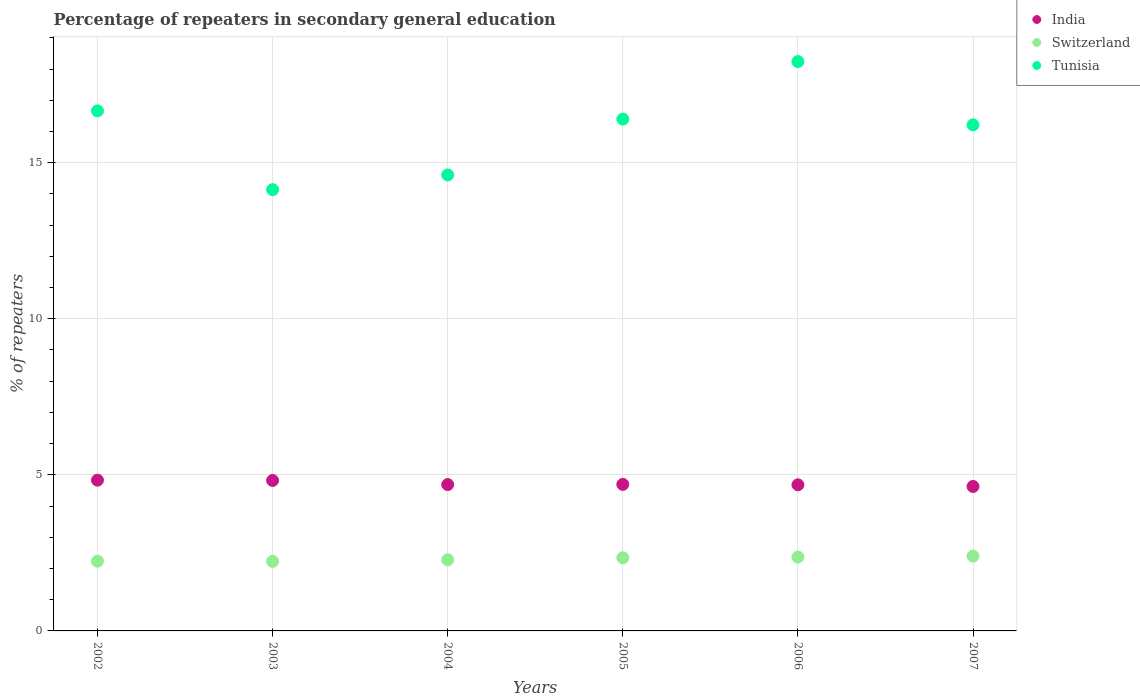How many different coloured dotlines are there?
Your answer should be very brief. 3. What is the percentage of repeaters in secondary general education in Switzerland in 2002?
Offer a terse response. 2.23. Across all years, what is the maximum percentage of repeaters in secondary general education in Switzerland?
Offer a very short reply. 2.4. Across all years, what is the minimum percentage of repeaters in secondary general education in India?
Your answer should be compact. 4.63. In which year was the percentage of repeaters in secondary general education in Tunisia maximum?
Provide a succinct answer. 2006. What is the total percentage of repeaters in secondary general education in Switzerland in the graph?
Your answer should be very brief. 13.85. What is the difference between the percentage of repeaters in secondary general education in Switzerland in 2002 and that in 2004?
Your answer should be very brief. -0.05. What is the difference between the percentage of repeaters in secondary general education in Tunisia in 2002 and the percentage of repeaters in secondary general education in India in 2007?
Your response must be concise. 12.03. What is the average percentage of repeaters in secondary general education in Switzerland per year?
Your answer should be very brief. 2.31. In the year 2007, what is the difference between the percentage of repeaters in secondary general education in India and percentage of repeaters in secondary general education in Tunisia?
Provide a short and direct response. -11.58. What is the ratio of the percentage of repeaters in secondary general education in India in 2005 to that in 2006?
Provide a short and direct response. 1. Is the difference between the percentage of repeaters in secondary general education in India in 2005 and 2006 greater than the difference between the percentage of repeaters in secondary general education in Tunisia in 2005 and 2006?
Provide a succinct answer. Yes. What is the difference between the highest and the second highest percentage of repeaters in secondary general education in Tunisia?
Give a very brief answer. 1.58. What is the difference between the highest and the lowest percentage of repeaters in secondary general education in India?
Your answer should be very brief. 0.2. In how many years, is the percentage of repeaters in secondary general education in Switzerland greater than the average percentage of repeaters in secondary general education in Switzerland taken over all years?
Ensure brevity in your answer.  3. Is the sum of the percentage of repeaters in secondary general education in India in 2006 and 2007 greater than the maximum percentage of repeaters in secondary general education in Switzerland across all years?
Keep it short and to the point. Yes. Is it the case that in every year, the sum of the percentage of repeaters in secondary general education in India and percentage of repeaters in secondary general education in Switzerland  is greater than the percentage of repeaters in secondary general education in Tunisia?
Make the answer very short. No. Does the percentage of repeaters in secondary general education in Tunisia monotonically increase over the years?
Offer a terse response. No. Is the percentage of repeaters in secondary general education in India strictly less than the percentage of repeaters in secondary general education in Tunisia over the years?
Ensure brevity in your answer.  Yes. What is the difference between two consecutive major ticks on the Y-axis?
Offer a very short reply. 5. Where does the legend appear in the graph?
Make the answer very short. Top right. What is the title of the graph?
Give a very brief answer. Percentage of repeaters in secondary general education. What is the label or title of the X-axis?
Provide a succinct answer. Years. What is the label or title of the Y-axis?
Offer a very short reply. % of repeaters. What is the % of repeaters of India in 2002?
Your response must be concise. 4.83. What is the % of repeaters in Switzerland in 2002?
Offer a terse response. 2.23. What is the % of repeaters of Tunisia in 2002?
Give a very brief answer. 16.66. What is the % of repeaters of India in 2003?
Offer a terse response. 4.82. What is the % of repeaters in Switzerland in 2003?
Give a very brief answer. 2.23. What is the % of repeaters of Tunisia in 2003?
Offer a terse response. 14.14. What is the % of repeaters of India in 2004?
Offer a terse response. 4.69. What is the % of repeaters in Switzerland in 2004?
Make the answer very short. 2.28. What is the % of repeaters of Tunisia in 2004?
Your response must be concise. 14.61. What is the % of repeaters of India in 2005?
Your answer should be very brief. 4.69. What is the % of repeaters of Switzerland in 2005?
Your answer should be very brief. 2.34. What is the % of repeaters of Tunisia in 2005?
Keep it short and to the point. 16.4. What is the % of repeaters in India in 2006?
Make the answer very short. 4.68. What is the % of repeaters of Switzerland in 2006?
Offer a very short reply. 2.37. What is the % of repeaters in Tunisia in 2006?
Offer a terse response. 18.24. What is the % of repeaters of India in 2007?
Make the answer very short. 4.63. What is the % of repeaters of Switzerland in 2007?
Offer a very short reply. 2.4. What is the % of repeaters in Tunisia in 2007?
Offer a terse response. 16.21. Across all years, what is the maximum % of repeaters of India?
Your answer should be very brief. 4.83. Across all years, what is the maximum % of repeaters of Switzerland?
Offer a terse response. 2.4. Across all years, what is the maximum % of repeaters of Tunisia?
Make the answer very short. 18.24. Across all years, what is the minimum % of repeaters in India?
Offer a terse response. 4.63. Across all years, what is the minimum % of repeaters in Switzerland?
Your response must be concise. 2.23. Across all years, what is the minimum % of repeaters of Tunisia?
Give a very brief answer. 14.14. What is the total % of repeaters of India in the graph?
Make the answer very short. 28.34. What is the total % of repeaters in Switzerland in the graph?
Give a very brief answer. 13.85. What is the total % of repeaters of Tunisia in the graph?
Give a very brief answer. 96.26. What is the difference between the % of repeaters of India in 2002 and that in 2003?
Give a very brief answer. 0.01. What is the difference between the % of repeaters of Switzerland in 2002 and that in 2003?
Keep it short and to the point. 0.01. What is the difference between the % of repeaters in Tunisia in 2002 and that in 2003?
Your answer should be compact. 2.52. What is the difference between the % of repeaters of India in 2002 and that in 2004?
Provide a short and direct response. 0.14. What is the difference between the % of repeaters in Switzerland in 2002 and that in 2004?
Give a very brief answer. -0.05. What is the difference between the % of repeaters of Tunisia in 2002 and that in 2004?
Ensure brevity in your answer.  2.05. What is the difference between the % of repeaters of India in 2002 and that in 2005?
Your answer should be compact. 0.13. What is the difference between the % of repeaters in Switzerland in 2002 and that in 2005?
Your response must be concise. -0.11. What is the difference between the % of repeaters in Tunisia in 2002 and that in 2005?
Make the answer very short. 0.26. What is the difference between the % of repeaters of India in 2002 and that in 2006?
Your answer should be very brief. 0.15. What is the difference between the % of repeaters of Switzerland in 2002 and that in 2006?
Provide a succinct answer. -0.13. What is the difference between the % of repeaters in Tunisia in 2002 and that in 2006?
Offer a terse response. -1.58. What is the difference between the % of repeaters of India in 2002 and that in 2007?
Provide a short and direct response. 0.2. What is the difference between the % of repeaters in Switzerland in 2002 and that in 2007?
Provide a succinct answer. -0.16. What is the difference between the % of repeaters of Tunisia in 2002 and that in 2007?
Your answer should be very brief. 0.45. What is the difference between the % of repeaters in India in 2003 and that in 2004?
Provide a succinct answer. 0.13. What is the difference between the % of repeaters of Switzerland in 2003 and that in 2004?
Your response must be concise. -0.05. What is the difference between the % of repeaters in Tunisia in 2003 and that in 2004?
Provide a short and direct response. -0.47. What is the difference between the % of repeaters in India in 2003 and that in 2005?
Give a very brief answer. 0.13. What is the difference between the % of repeaters of Switzerland in 2003 and that in 2005?
Offer a terse response. -0.12. What is the difference between the % of repeaters in Tunisia in 2003 and that in 2005?
Give a very brief answer. -2.26. What is the difference between the % of repeaters in India in 2003 and that in 2006?
Keep it short and to the point. 0.14. What is the difference between the % of repeaters of Switzerland in 2003 and that in 2006?
Make the answer very short. -0.14. What is the difference between the % of repeaters in Tunisia in 2003 and that in 2006?
Keep it short and to the point. -4.1. What is the difference between the % of repeaters of India in 2003 and that in 2007?
Your response must be concise. 0.19. What is the difference between the % of repeaters in Switzerland in 2003 and that in 2007?
Provide a short and direct response. -0.17. What is the difference between the % of repeaters of Tunisia in 2003 and that in 2007?
Your answer should be very brief. -2.08. What is the difference between the % of repeaters of India in 2004 and that in 2005?
Ensure brevity in your answer.  -0.01. What is the difference between the % of repeaters in Switzerland in 2004 and that in 2005?
Keep it short and to the point. -0.06. What is the difference between the % of repeaters of Tunisia in 2004 and that in 2005?
Offer a terse response. -1.79. What is the difference between the % of repeaters of India in 2004 and that in 2006?
Your response must be concise. 0.01. What is the difference between the % of repeaters of Switzerland in 2004 and that in 2006?
Your answer should be compact. -0.09. What is the difference between the % of repeaters in Tunisia in 2004 and that in 2006?
Give a very brief answer. -3.63. What is the difference between the % of repeaters in India in 2004 and that in 2007?
Make the answer very short. 0.06. What is the difference between the % of repeaters in Switzerland in 2004 and that in 2007?
Your response must be concise. -0.12. What is the difference between the % of repeaters in Tunisia in 2004 and that in 2007?
Provide a short and direct response. -1.6. What is the difference between the % of repeaters of India in 2005 and that in 2006?
Provide a short and direct response. 0.01. What is the difference between the % of repeaters in Switzerland in 2005 and that in 2006?
Make the answer very short. -0.02. What is the difference between the % of repeaters of Tunisia in 2005 and that in 2006?
Make the answer very short. -1.84. What is the difference between the % of repeaters of India in 2005 and that in 2007?
Your answer should be very brief. 0.07. What is the difference between the % of repeaters in Switzerland in 2005 and that in 2007?
Keep it short and to the point. -0.05. What is the difference between the % of repeaters of Tunisia in 2005 and that in 2007?
Provide a short and direct response. 0.19. What is the difference between the % of repeaters in India in 2006 and that in 2007?
Ensure brevity in your answer.  0.05. What is the difference between the % of repeaters of Switzerland in 2006 and that in 2007?
Your answer should be compact. -0.03. What is the difference between the % of repeaters in Tunisia in 2006 and that in 2007?
Keep it short and to the point. 2.03. What is the difference between the % of repeaters of India in 2002 and the % of repeaters of Switzerland in 2003?
Offer a very short reply. 2.6. What is the difference between the % of repeaters in India in 2002 and the % of repeaters in Tunisia in 2003?
Your answer should be compact. -9.31. What is the difference between the % of repeaters in Switzerland in 2002 and the % of repeaters in Tunisia in 2003?
Provide a short and direct response. -11.9. What is the difference between the % of repeaters of India in 2002 and the % of repeaters of Switzerland in 2004?
Your answer should be very brief. 2.55. What is the difference between the % of repeaters in India in 2002 and the % of repeaters in Tunisia in 2004?
Provide a succinct answer. -9.78. What is the difference between the % of repeaters in Switzerland in 2002 and the % of repeaters in Tunisia in 2004?
Ensure brevity in your answer.  -12.38. What is the difference between the % of repeaters of India in 2002 and the % of repeaters of Switzerland in 2005?
Offer a very short reply. 2.49. What is the difference between the % of repeaters of India in 2002 and the % of repeaters of Tunisia in 2005?
Provide a succinct answer. -11.57. What is the difference between the % of repeaters of Switzerland in 2002 and the % of repeaters of Tunisia in 2005?
Provide a succinct answer. -14.16. What is the difference between the % of repeaters of India in 2002 and the % of repeaters of Switzerland in 2006?
Make the answer very short. 2.46. What is the difference between the % of repeaters in India in 2002 and the % of repeaters in Tunisia in 2006?
Your answer should be compact. -13.41. What is the difference between the % of repeaters in Switzerland in 2002 and the % of repeaters in Tunisia in 2006?
Give a very brief answer. -16.01. What is the difference between the % of repeaters in India in 2002 and the % of repeaters in Switzerland in 2007?
Ensure brevity in your answer.  2.43. What is the difference between the % of repeaters of India in 2002 and the % of repeaters of Tunisia in 2007?
Make the answer very short. -11.38. What is the difference between the % of repeaters in Switzerland in 2002 and the % of repeaters in Tunisia in 2007?
Offer a terse response. -13.98. What is the difference between the % of repeaters of India in 2003 and the % of repeaters of Switzerland in 2004?
Offer a very short reply. 2.54. What is the difference between the % of repeaters of India in 2003 and the % of repeaters of Tunisia in 2004?
Your answer should be very brief. -9.79. What is the difference between the % of repeaters of Switzerland in 2003 and the % of repeaters of Tunisia in 2004?
Your answer should be compact. -12.38. What is the difference between the % of repeaters of India in 2003 and the % of repeaters of Switzerland in 2005?
Your response must be concise. 2.48. What is the difference between the % of repeaters in India in 2003 and the % of repeaters in Tunisia in 2005?
Make the answer very short. -11.58. What is the difference between the % of repeaters in Switzerland in 2003 and the % of repeaters in Tunisia in 2005?
Keep it short and to the point. -14.17. What is the difference between the % of repeaters of India in 2003 and the % of repeaters of Switzerland in 2006?
Offer a very short reply. 2.45. What is the difference between the % of repeaters of India in 2003 and the % of repeaters of Tunisia in 2006?
Your answer should be very brief. -13.42. What is the difference between the % of repeaters in Switzerland in 2003 and the % of repeaters in Tunisia in 2006?
Your answer should be compact. -16.01. What is the difference between the % of repeaters in India in 2003 and the % of repeaters in Switzerland in 2007?
Offer a very short reply. 2.42. What is the difference between the % of repeaters in India in 2003 and the % of repeaters in Tunisia in 2007?
Your response must be concise. -11.39. What is the difference between the % of repeaters in Switzerland in 2003 and the % of repeaters in Tunisia in 2007?
Provide a succinct answer. -13.98. What is the difference between the % of repeaters in India in 2004 and the % of repeaters in Switzerland in 2005?
Your response must be concise. 2.34. What is the difference between the % of repeaters in India in 2004 and the % of repeaters in Tunisia in 2005?
Provide a short and direct response. -11.71. What is the difference between the % of repeaters in Switzerland in 2004 and the % of repeaters in Tunisia in 2005?
Ensure brevity in your answer.  -14.12. What is the difference between the % of repeaters in India in 2004 and the % of repeaters in Switzerland in 2006?
Make the answer very short. 2.32. What is the difference between the % of repeaters in India in 2004 and the % of repeaters in Tunisia in 2006?
Provide a short and direct response. -13.55. What is the difference between the % of repeaters of Switzerland in 2004 and the % of repeaters of Tunisia in 2006?
Offer a very short reply. -15.96. What is the difference between the % of repeaters in India in 2004 and the % of repeaters in Switzerland in 2007?
Provide a succinct answer. 2.29. What is the difference between the % of repeaters in India in 2004 and the % of repeaters in Tunisia in 2007?
Ensure brevity in your answer.  -11.52. What is the difference between the % of repeaters of Switzerland in 2004 and the % of repeaters of Tunisia in 2007?
Give a very brief answer. -13.93. What is the difference between the % of repeaters in India in 2005 and the % of repeaters in Switzerland in 2006?
Keep it short and to the point. 2.33. What is the difference between the % of repeaters of India in 2005 and the % of repeaters of Tunisia in 2006?
Keep it short and to the point. -13.55. What is the difference between the % of repeaters of Switzerland in 2005 and the % of repeaters of Tunisia in 2006?
Give a very brief answer. -15.9. What is the difference between the % of repeaters in India in 2005 and the % of repeaters in Switzerland in 2007?
Keep it short and to the point. 2.3. What is the difference between the % of repeaters of India in 2005 and the % of repeaters of Tunisia in 2007?
Your response must be concise. -11.52. What is the difference between the % of repeaters in Switzerland in 2005 and the % of repeaters in Tunisia in 2007?
Your response must be concise. -13.87. What is the difference between the % of repeaters of India in 2006 and the % of repeaters of Switzerland in 2007?
Make the answer very short. 2.28. What is the difference between the % of repeaters of India in 2006 and the % of repeaters of Tunisia in 2007?
Give a very brief answer. -11.53. What is the difference between the % of repeaters in Switzerland in 2006 and the % of repeaters in Tunisia in 2007?
Provide a succinct answer. -13.85. What is the average % of repeaters in India per year?
Your answer should be compact. 4.72. What is the average % of repeaters of Switzerland per year?
Give a very brief answer. 2.31. What is the average % of repeaters of Tunisia per year?
Provide a succinct answer. 16.04. In the year 2002, what is the difference between the % of repeaters of India and % of repeaters of Switzerland?
Give a very brief answer. 2.6. In the year 2002, what is the difference between the % of repeaters in India and % of repeaters in Tunisia?
Your answer should be compact. -11.83. In the year 2002, what is the difference between the % of repeaters of Switzerland and % of repeaters of Tunisia?
Your response must be concise. -14.43. In the year 2003, what is the difference between the % of repeaters in India and % of repeaters in Switzerland?
Make the answer very short. 2.59. In the year 2003, what is the difference between the % of repeaters of India and % of repeaters of Tunisia?
Offer a terse response. -9.32. In the year 2003, what is the difference between the % of repeaters in Switzerland and % of repeaters in Tunisia?
Your response must be concise. -11.91. In the year 2004, what is the difference between the % of repeaters of India and % of repeaters of Switzerland?
Provide a short and direct response. 2.41. In the year 2004, what is the difference between the % of repeaters in India and % of repeaters in Tunisia?
Make the answer very short. -9.92. In the year 2004, what is the difference between the % of repeaters in Switzerland and % of repeaters in Tunisia?
Make the answer very short. -12.33. In the year 2005, what is the difference between the % of repeaters in India and % of repeaters in Switzerland?
Give a very brief answer. 2.35. In the year 2005, what is the difference between the % of repeaters of India and % of repeaters of Tunisia?
Your response must be concise. -11.7. In the year 2005, what is the difference between the % of repeaters in Switzerland and % of repeaters in Tunisia?
Offer a very short reply. -14.05. In the year 2006, what is the difference between the % of repeaters in India and % of repeaters in Switzerland?
Your answer should be very brief. 2.31. In the year 2006, what is the difference between the % of repeaters of India and % of repeaters of Tunisia?
Make the answer very short. -13.56. In the year 2006, what is the difference between the % of repeaters of Switzerland and % of repeaters of Tunisia?
Offer a terse response. -15.87. In the year 2007, what is the difference between the % of repeaters in India and % of repeaters in Switzerland?
Make the answer very short. 2.23. In the year 2007, what is the difference between the % of repeaters in India and % of repeaters in Tunisia?
Provide a succinct answer. -11.58. In the year 2007, what is the difference between the % of repeaters in Switzerland and % of repeaters in Tunisia?
Keep it short and to the point. -13.82. What is the ratio of the % of repeaters of Tunisia in 2002 to that in 2003?
Your answer should be compact. 1.18. What is the ratio of the % of repeaters in Switzerland in 2002 to that in 2004?
Your response must be concise. 0.98. What is the ratio of the % of repeaters of Tunisia in 2002 to that in 2004?
Keep it short and to the point. 1.14. What is the ratio of the % of repeaters of India in 2002 to that in 2005?
Provide a short and direct response. 1.03. What is the ratio of the % of repeaters in Switzerland in 2002 to that in 2005?
Provide a short and direct response. 0.95. What is the ratio of the % of repeaters of India in 2002 to that in 2006?
Keep it short and to the point. 1.03. What is the ratio of the % of repeaters of Switzerland in 2002 to that in 2006?
Offer a very short reply. 0.94. What is the ratio of the % of repeaters of Tunisia in 2002 to that in 2006?
Offer a terse response. 0.91. What is the ratio of the % of repeaters in India in 2002 to that in 2007?
Your answer should be very brief. 1.04. What is the ratio of the % of repeaters in Switzerland in 2002 to that in 2007?
Your response must be concise. 0.93. What is the ratio of the % of repeaters in Tunisia in 2002 to that in 2007?
Provide a succinct answer. 1.03. What is the ratio of the % of repeaters of India in 2003 to that in 2004?
Offer a terse response. 1.03. What is the ratio of the % of repeaters in Switzerland in 2003 to that in 2004?
Give a very brief answer. 0.98. What is the ratio of the % of repeaters of Tunisia in 2003 to that in 2004?
Keep it short and to the point. 0.97. What is the ratio of the % of repeaters in India in 2003 to that in 2005?
Offer a terse response. 1.03. What is the ratio of the % of repeaters of Switzerland in 2003 to that in 2005?
Ensure brevity in your answer.  0.95. What is the ratio of the % of repeaters in Tunisia in 2003 to that in 2005?
Your answer should be compact. 0.86. What is the ratio of the % of repeaters in India in 2003 to that in 2006?
Offer a terse response. 1.03. What is the ratio of the % of repeaters in Switzerland in 2003 to that in 2006?
Give a very brief answer. 0.94. What is the ratio of the % of repeaters in Tunisia in 2003 to that in 2006?
Give a very brief answer. 0.78. What is the ratio of the % of repeaters in India in 2003 to that in 2007?
Give a very brief answer. 1.04. What is the ratio of the % of repeaters of Tunisia in 2003 to that in 2007?
Give a very brief answer. 0.87. What is the ratio of the % of repeaters of Switzerland in 2004 to that in 2005?
Make the answer very short. 0.97. What is the ratio of the % of repeaters in Tunisia in 2004 to that in 2005?
Your response must be concise. 0.89. What is the ratio of the % of repeaters of Switzerland in 2004 to that in 2006?
Ensure brevity in your answer.  0.96. What is the ratio of the % of repeaters in Tunisia in 2004 to that in 2006?
Provide a succinct answer. 0.8. What is the ratio of the % of repeaters in India in 2004 to that in 2007?
Ensure brevity in your answer.  1.01. What is the ratio of the % of repeaters of Switzerland in 2004 to that in 2007?
Your response must be concise. 0.95. What is the ratio of the % of repeaters in Tunisia in 2004 to that in 2007?
Provide a short and direct response. 0.9. What is the ratio of the % of repeaters of India in 2005 to that in 2006?
Make the answer very short. 1. What is the ratio of the % of repeaters of Switzerland in 2005 to that in 2006?
Offer a terse response. 0.99. What is the ratio of the % of repeaters of Tunisia in 2005 to that in 2006?
Provide a succinct answer. 0.9. What is the ratio of the % of repeaters in India in 2005 to that in 2007?
Your response must be concise. 1.01. What is the ratio of the % of repeaters in Switzerland in 2005 to that in 2007?
Keep it short and to the point. 0.98. What is the ratio of the % of repeaters in Tunisia in 2005 to that in 2007?
Provide a succinct answer. 1.01. What is the ratio of the % of repeaters in India in 2006 to that in 2007?
Provide a short and direct response. 1.01. What is the ratio of the % of repeaters of Switzerland in 2006 to that in 2007?
Offer a very short reply. 0.99. What is the ratio of the % of repeaters of Tunisia in 2006 to that in 2007?
Make the answer very short. 1.13. What is the difference between the highest and the second highest % of repeaters of India?
Offer a very short reply. 0.01. What is the difference between the highest and the second highest % of repeaters in Switzerland?
Give a very brief answer. 0.03. What is the difference between the highest and the second highest % of repeaters in Tunisia?
Your response must be concise. 1.58. What is the difference between the highest and the lowest % of repeaters in India?
Provide a succinct answer. 0.2. What is the difference between the highest and the lowest % of repeaters of Switzerland?
Your response must be concise. 0.17. What is the difference between the highest and the lowest % of repeaters in Tunisia?
Offer a very short reply. 4.1. 